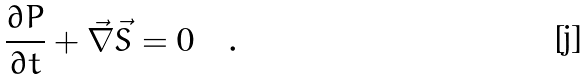Convert formula to latex. <formula><loc_0><loc_0><loc_500><loc_500>\frac { \partial P } { \partial t } + \vec { \nabla } \vec { S } = 0 \quad .</formula> 